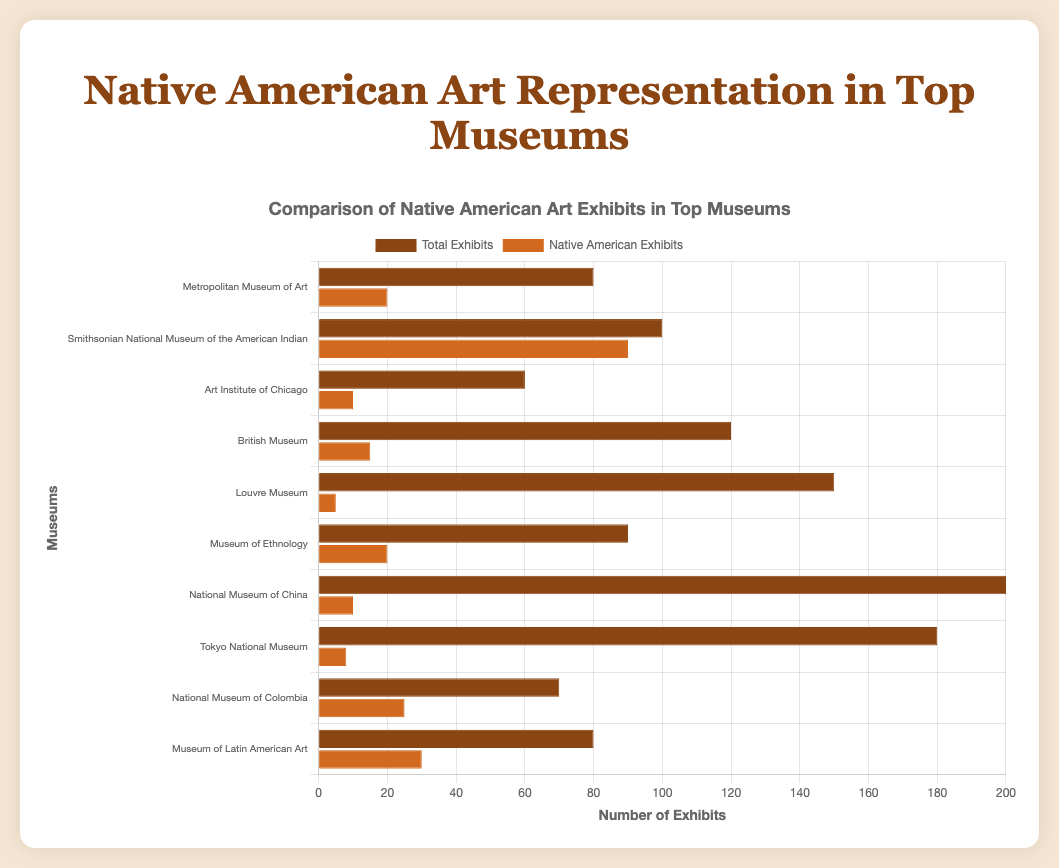What's the range of Native American exhibits across all museums? The range is found by calculating the difference between the maximum and minimum values of Native American exhibits. The maximum is 90 (Smithsonian National Museum of the American Indian) and the minimum is 5 (Louvre Museum). The range is 90 - 5 = 85.
Answer: 85 Which museum in North America has the least number of Native American exhibits? From the chart, the museums in North America and their Native American exhibits are: Metropolitan Museum of Art (20), Smithsonian National Museum of the American Indian (90), and Art Institute of Chicago (10). The Art Institute of Chicago has the least number, which is 10.
Answer: Art Institute of Chicago Is the number of Native American exhibits at the Smithsonian National Museum of the American Indian greater than the total exhibits at the Art Institute of Chicago? The Smithsonian National Museum of the American Indian has 90 Native American exhibits, whereas the Art Institute of Chicago has a total of 60 exhibits. By comparison, 90 (Native American exhibits) > 60 (total exhibits).
Answer: Yes What is the sum of Native American exhibits in all European museums? The Native American exhibits in European museums are: British Museum (15), Louvre Museum (5), and Museum of Ethnology (20). Sum these values: 15 + 5 + 20 = 40.
Answer: 40 Which museum has the highest percentage of Native American exhibits relative to its total exhibits, and what is the percentage? To find this, calculate the percentage of Native American exhibits relative to total exhibits for each museum and compare them. The Smithsonian National Museum of the American Indian has the highest percentage: \( \frac{90}{100} \) * 100% = 90%.
Answer: Smithsonian National Museum of the American Indian, 90% How many museums in Asia exhibit more than 5 Native American art pieces? The museums in Asia are the National Museum of China (10 Native American exhibits) and Tokyo National Museum (8 Native American exhibits). Both have more than 5 Native American exhibits.
Answer: 2 What's the difference in Native American exhibits between the National Museum of Colombia and the Museum of Latin American Art? The National Museum of Colombia has 25 Native American exhibits and the Museum of Latin American Art has 30. The difference is 30 - 25 = 5.
Answer: 5 Which museum has the fewest total exhibits and how many are there? The museums and their total exhibits are: Metropolitan Museum of Art (80), Smithsonian National Museum of the American Indian (100), Art Institute of Chicago (60), British Museum (120), Louvre Museum (150), Museum of Ethnology (90), National Museum of China (200), Tokyo National Museum (180), National Museum of Colombia (70), and Museum of Latin American Art (80). The Art Institute of Chicago has the fewest total exhibits with 60.
Answer: Art Institute of Chicago, 60 What is the visual difference between Native American exhibits and non-Native American exhibits at the Metropolitan Museum of Art? The horizontal bar representing Native American exhibits at the Metropolitan Museum of Art is 1/4th the length of the bar representing total exhibits. That indicates that out of 80 total exhibits, 20 are Native American, meaning 60 (3/4ths) are non-Native American.
Answer: The non-Native American exhibits bar is 3/4th of the total exhibits bar 